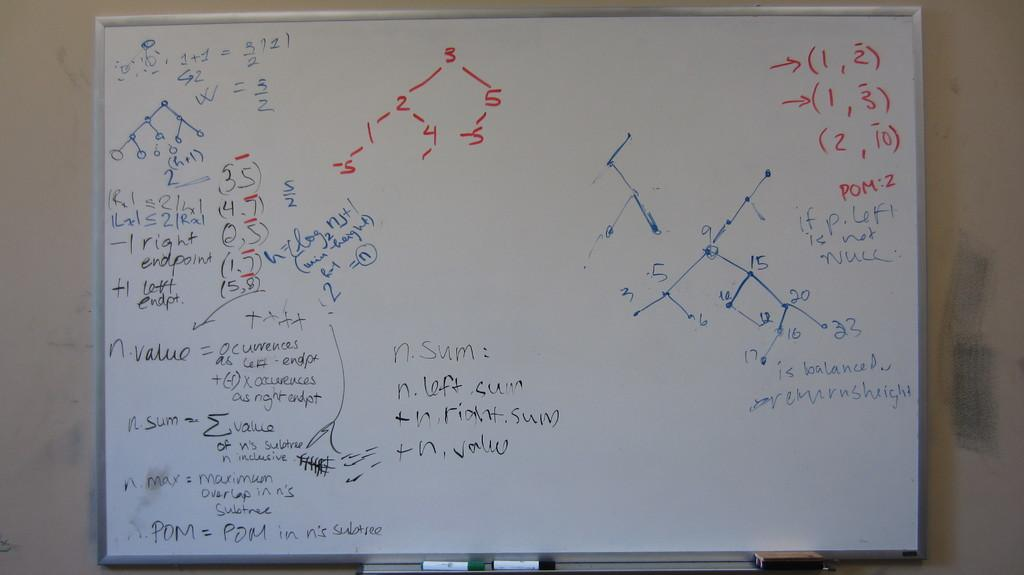<image>
Provide a brief description of the given image. A white board has a list in the middle that includes n.sum and n.left.sum. 